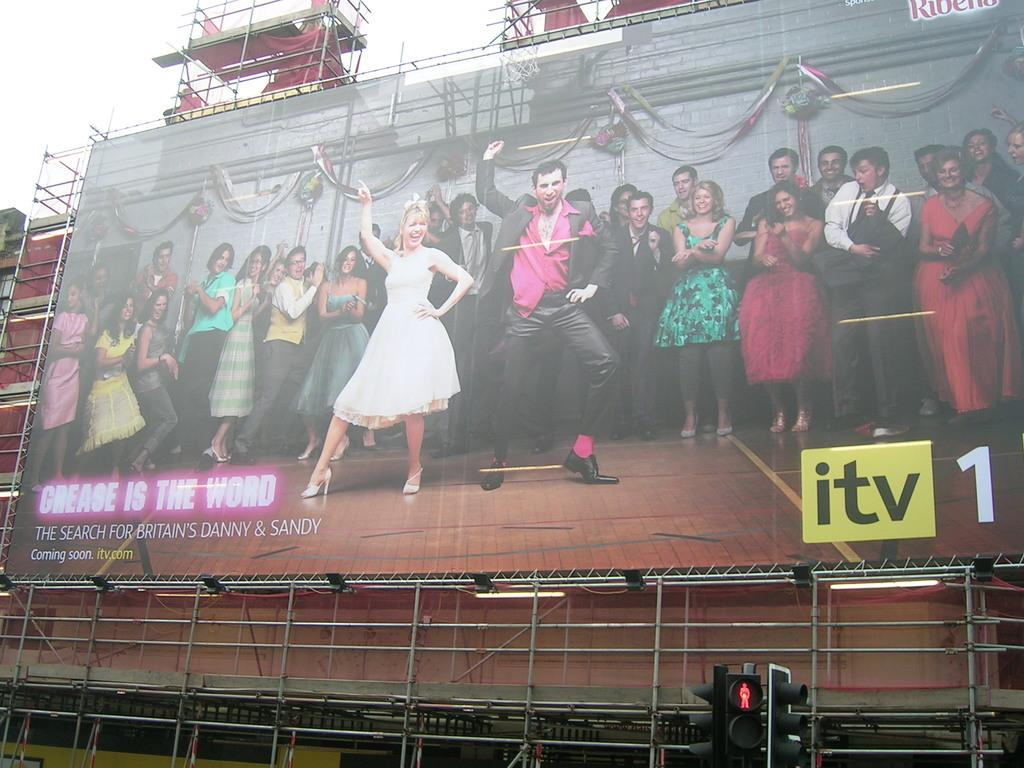<image>
Present a compact description of the photo's key features. A large poster for a grease play with the tage "Grease is the word" on the left. 